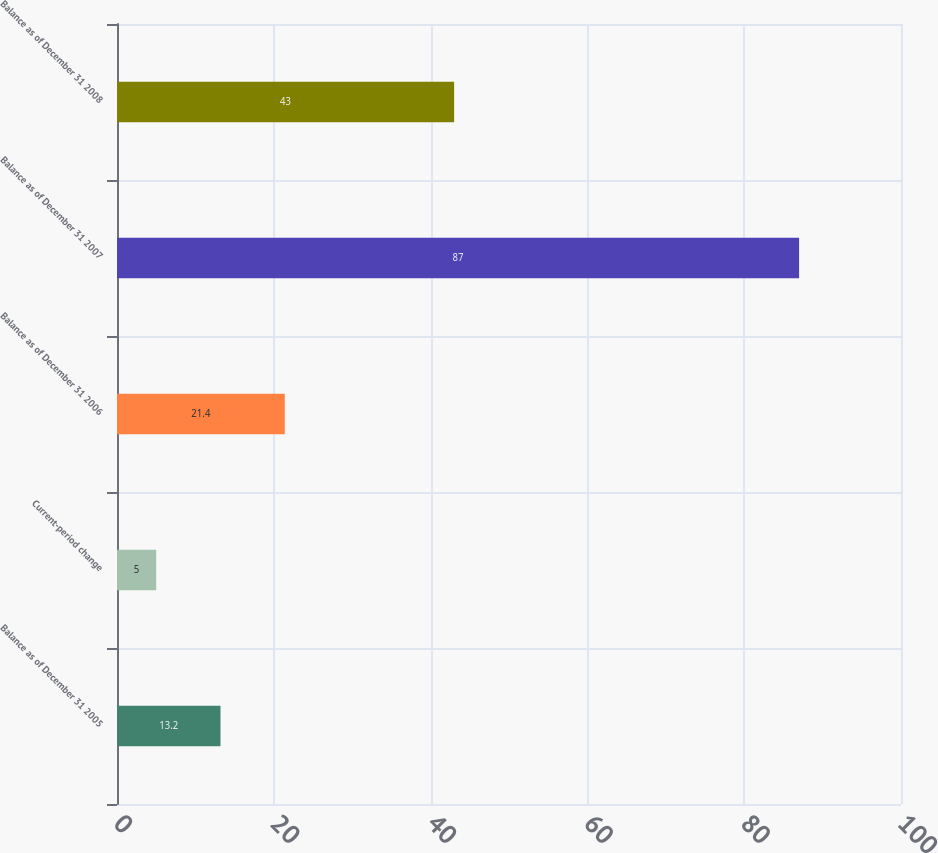Convert chart. <chart><loc_0><loc_0><loc_500><loc_500><bar_chart><fcel>Balance as of December 31 2005<fcel>Current-period change<fcel>Balance as of December 31 2006<fcel>Balance as of December 31 2007<fcel>Balance as of December 31 2008<nl><fcel>13.2<fcel>5<fcel>21.4<fcel>87<fcel>43<nl></chart> 